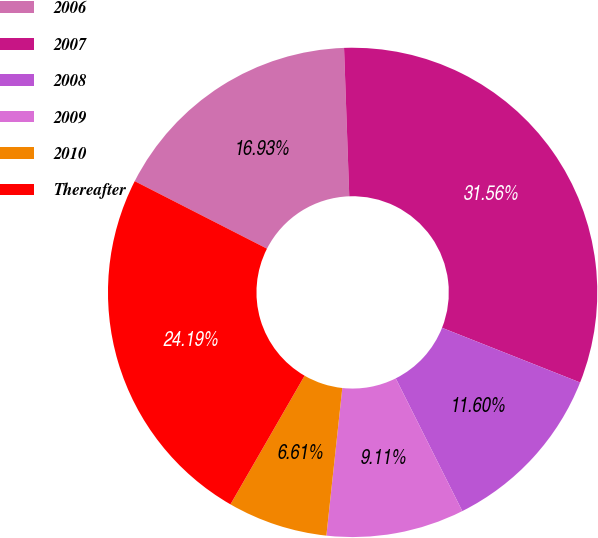Convert chart to OTSL. <chart><loc_0><loc_0><loc_500><loc_500><pie_chart><fcel>2006<fcel>2007<fcel>2008<fcel>2009<fcel>2010<fcel>Thereafter<nl><fcel>16.93%<fcel>31.56%<fcel>11.6%<fcel>9.11%<fcel>6.61%<fcel>24.19%<nl></chart> 